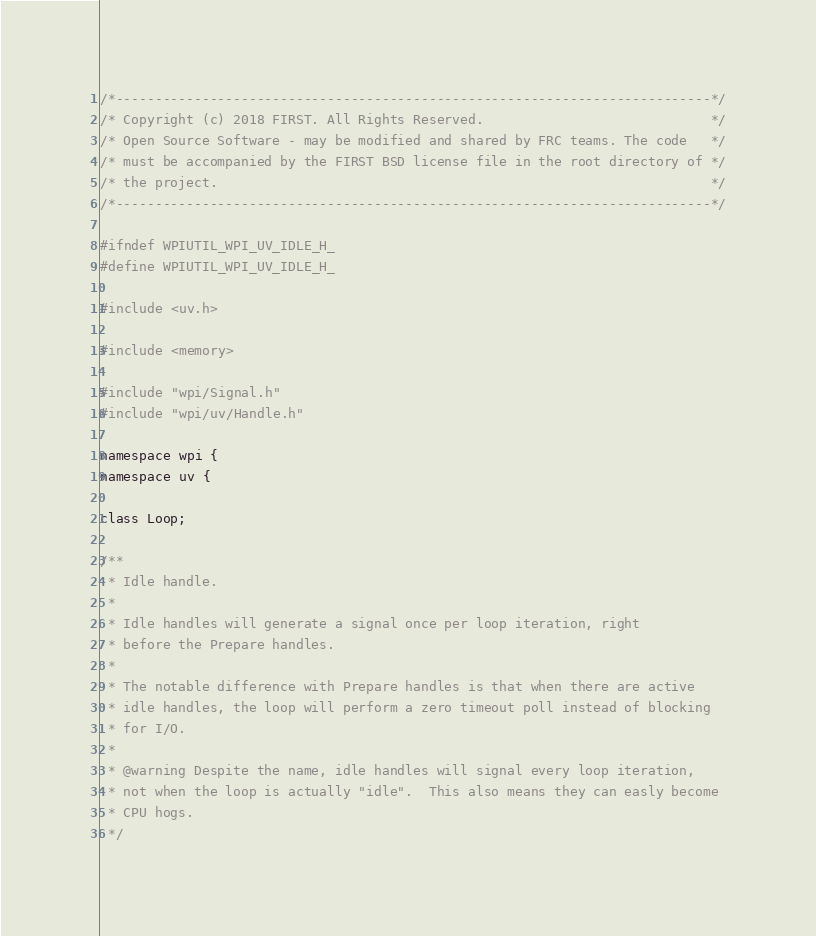Convert code to text. <code><loc_0><loc_0><loc_500><loc_500><_C_>/*----------------------------------------------------------------------------*/
/* Copyright (c) 2018 FIRST. All Rights Reserved.                             */
/* Open Source Software - may be modified and shared by FRC teams. The code   */
/* must be accompanied by the FIRST BSD license file in the root directory of */
/* the project.                                                               */
/*----------------------------------------------------------------------------*/

#ifndef WPIUTIL_WPI_UV_IDLE_H_
#define WPIUTIL_WPI_UV_IDLE_H_

#include <uv.h>

#include <memory>

#include "wpi/Signal.h"
#include "wpi/uv/Handle.h"

namespace wpi {
namespace uv {

class Loop;

/**
 * Idle handle.
 *
 * Idle handles will generate a signal once per loop iteration, right
 * before the Prepare handles.
 *
 * The notable difference with Prepare handles is that when there are active
 * idle handles, the loop will perform a zero timeout poll instead of blocking
 * for I/O.
 *
 * @warning Despite the name, idle handles will signal every loop iteration,
 * not when the loop is actually "idle".  This also means they can easly become
 * CPU hogs.
 */</code> 